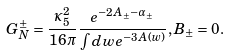Convert formula to latex. <formula><loc_0><loc_0><loc_500><loc_500>G _ { N } ^ { \pm } = \frac { \kappa _ { 5 } ^ { 2 } } { 1 6 \pi } \frac { e ^ { - 2 A _ { \pm } - \alpha _ { \pm } } } { \int d w e ^ { - 3 A ( w ) } } , B _ { \pm } = 0 .</formula> 